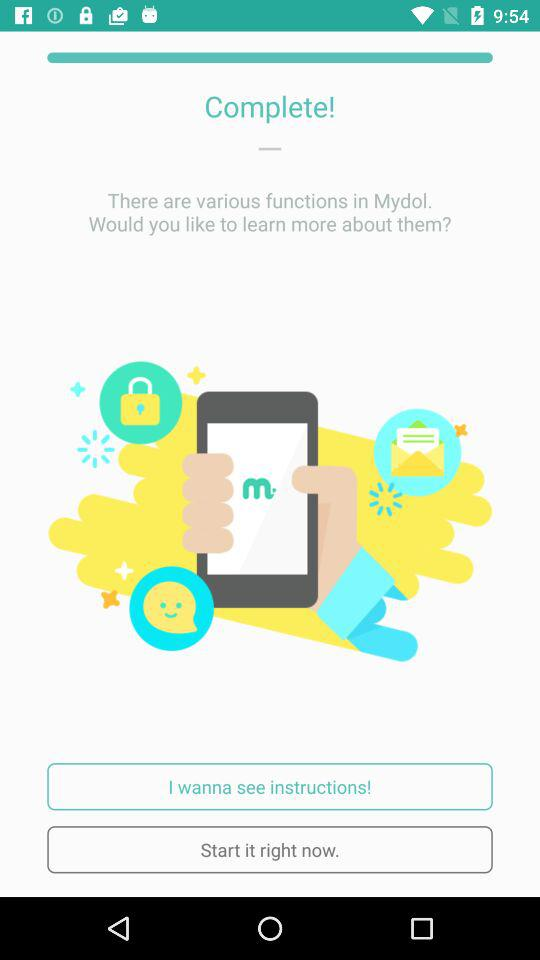What is the application name? The application name is "Mydol". 